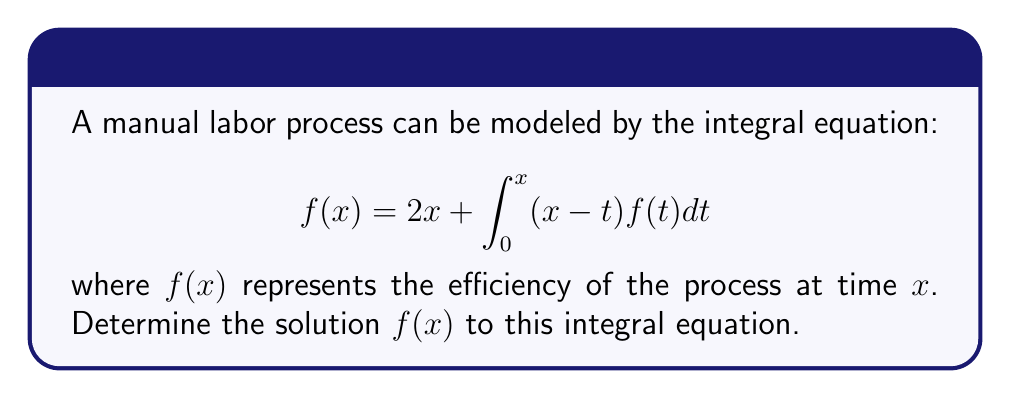Could you help me with this problem? To solve this integral equation, we'll follow these steps:

1) First, we differentiate both sides of the equation with respect to $x$:

   $$f'(x) = 2 + \int_0^x f(t)dt + (x-x)f(x) = 2 + \int_0^x f(t)dt$$

2) Differentiate again:

   $$f''(x) = f(x)$$

3) This is a second-order differential equation. The general solution is:

   $$f(x) = c_1e^x + c_2e^{-x}$$

4) To find $c_1$ and $c_2$, we use the original equation. Substitute the general solution:

   $$c_1e^x + c_2e^{-x} = 2x + \int_0^x (x-t)(c_1e^t + c_2e^{-t})dt$$

5) Evaluate the integral:

   $$c_1e^x + c_2e^{-x} = 2x + c_1(xe^x - e^x + 1) + c_2(xe^{-x} + e^{-x} - 1)$$

6) For this to be true for all $x$, coefficients must match:

   For $e^x$: $c_1 = c_1 - c_1 = 0$
   For $e^{-x}$: $c_2 = c_2 + c_2 = 2c_2$
   For $x$: $0 = 2 + c_1 + c_2$

7) From these, we get:

   $c_1 = 0$
   $c_2 = 2$
   $2 + c_1 + c_2 = 2 + 0 + 2 = 4$

8) Therefore, the solution is:

   $$f(x) = 2e^{-x}$$
Answer: $f(x) = 2e^{-x}$ 